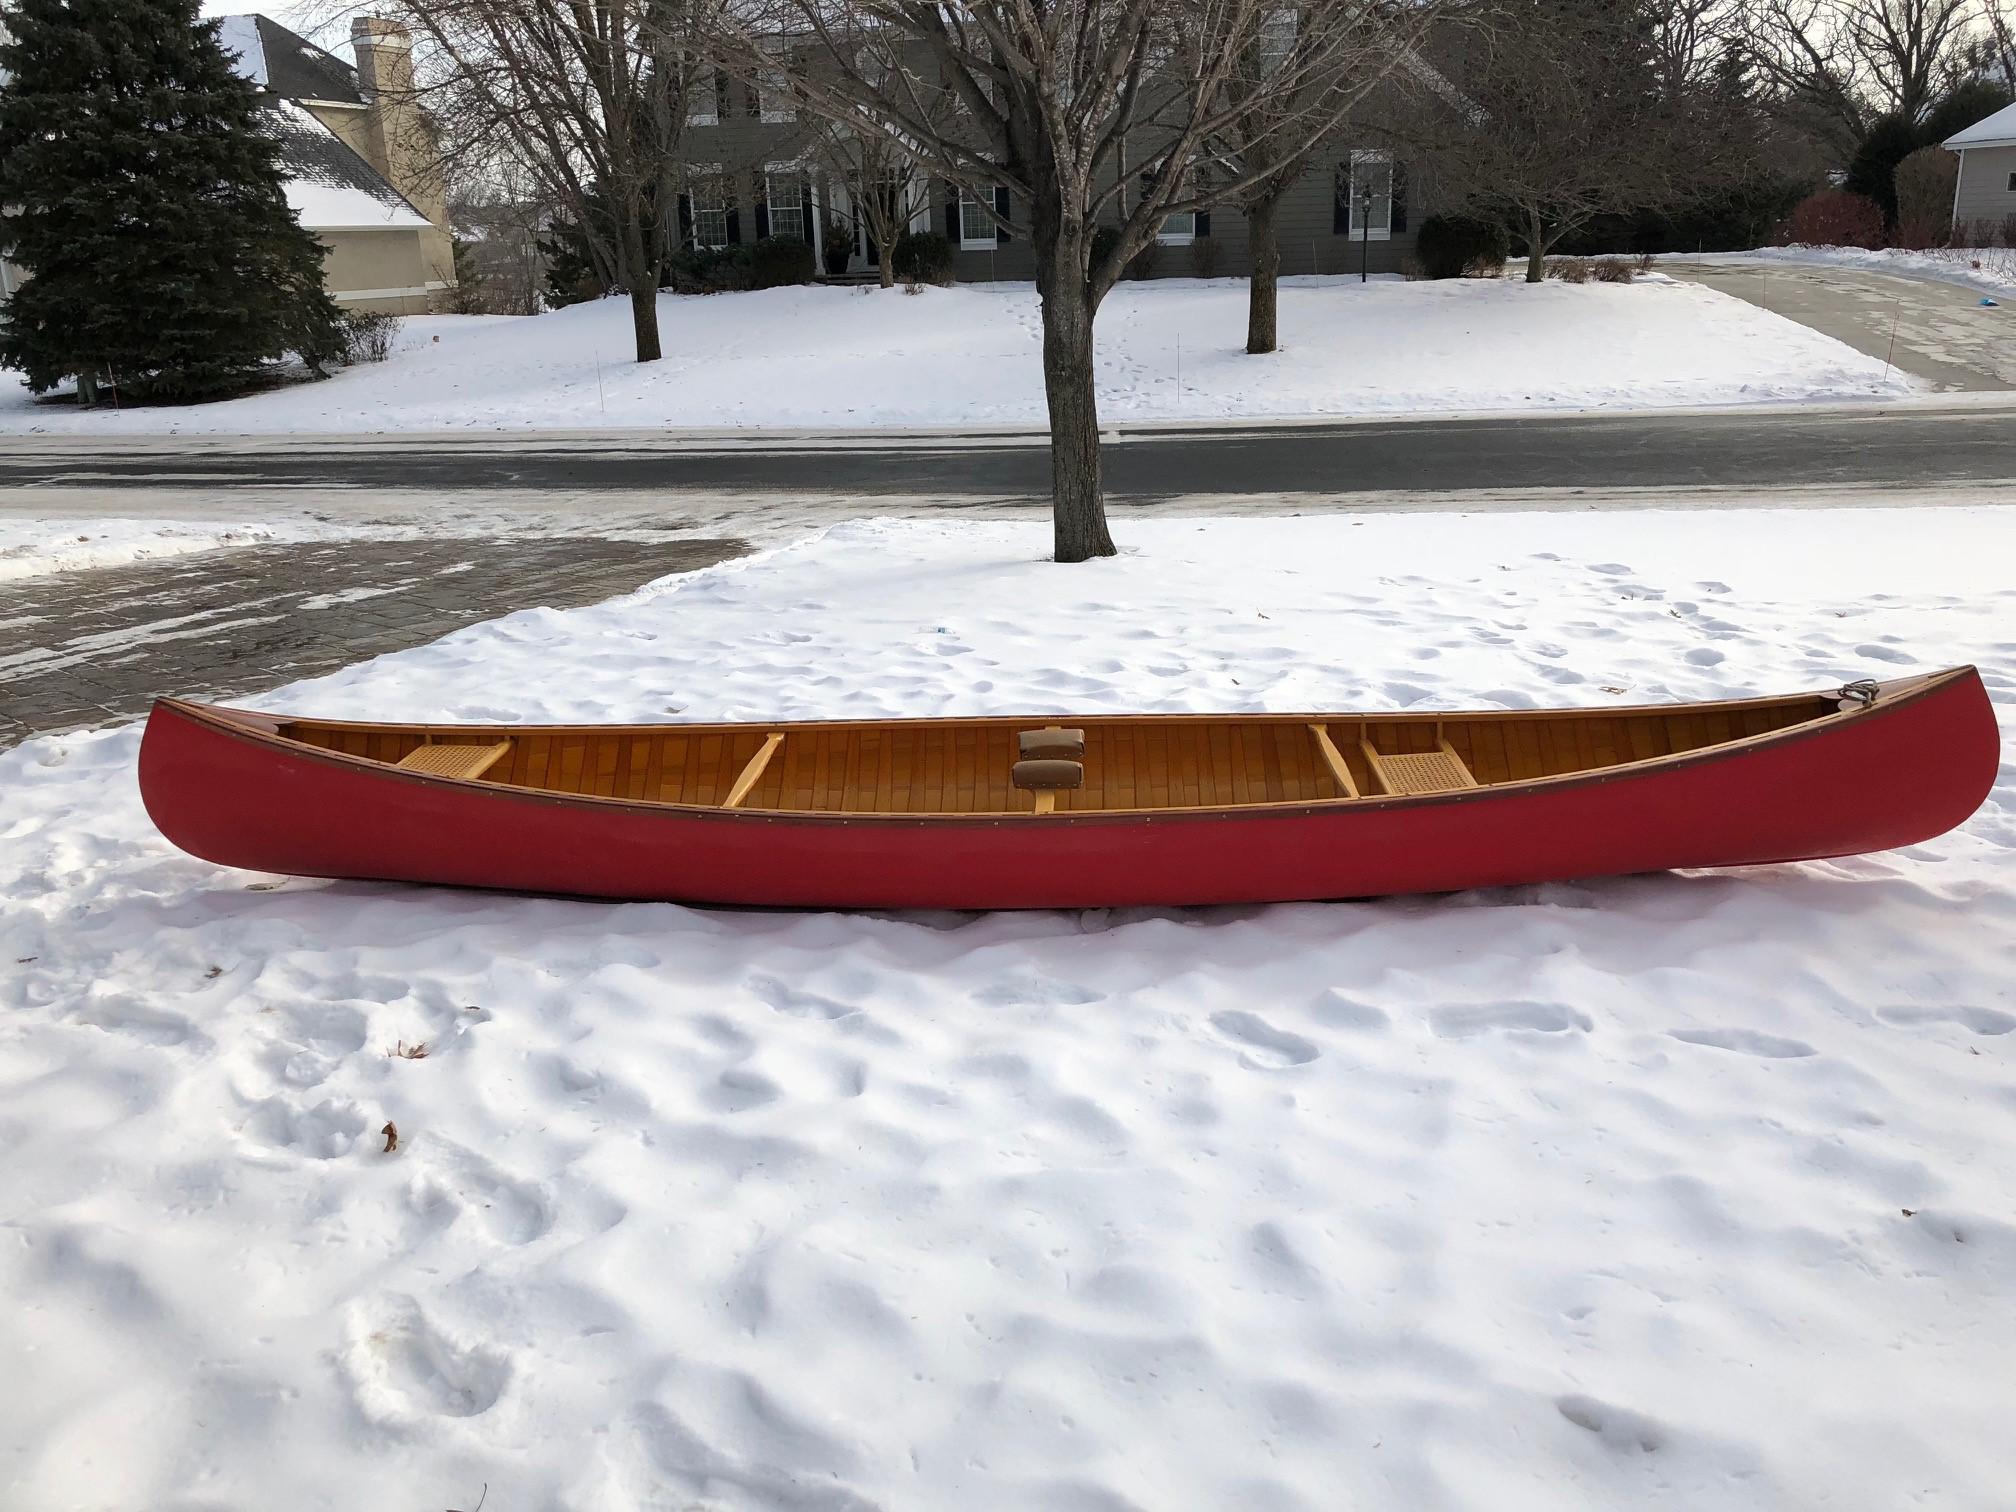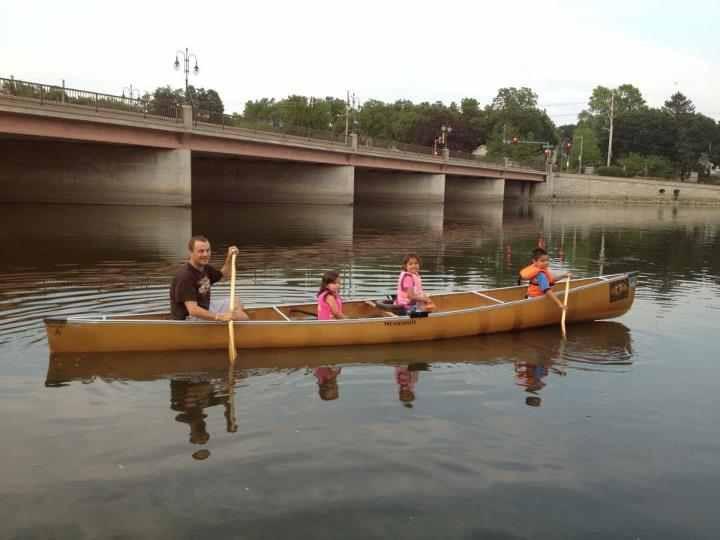The first image is the image on the left, the second image is the image on the right. Evaluate the accuracy of this statement regarding the images: "The left and right image contains the same number of boat on land.". Is it true? Answer yes or no. No. The first image is the image on the left, the second image is the image on the right. Analyze the images presented: Is the assertion "Two canoes are sitting on the ground." valid? Answer yes or no. No. 